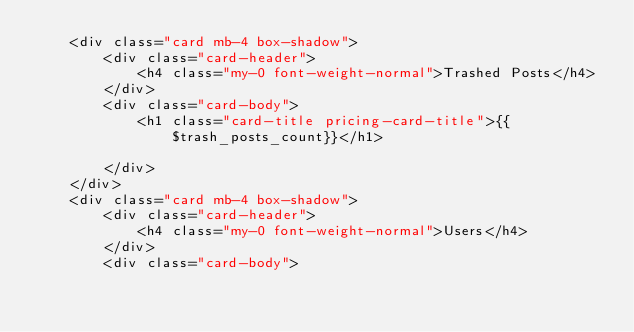Convert code to text. <code><loc_0><loc_0><loc_500><loc_500><_PHP_>    <div class="card mb-4 box-shadow">
        <div class="card-header">
            <h4 class="my-0 font-weight-normal">Trashed Posts</h4>
        </div>
        <div class="card-body">
            <h1 class="card-title pricing-card-title">{{$trash_posts_count}}</h1>

        </div>
    </div>
    <div class="card mb-4 box-shadow">
        <div class="card-header">
            <h4 class="my-0 font-weight-normal">Users</h4>
        </div>
        <div class="card-body"></code> 